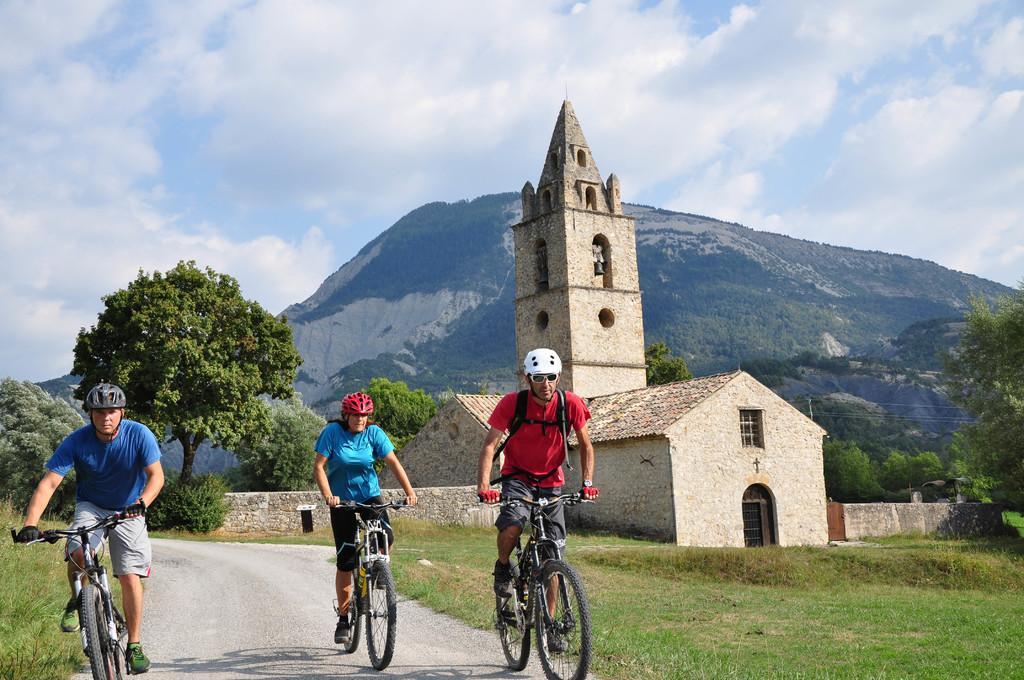How would you summarize this image in a sentence or two? In this image we can see people riding bicycles on the road, buildings, trees, electric poles, electric cables, hills and sky with clouds. 